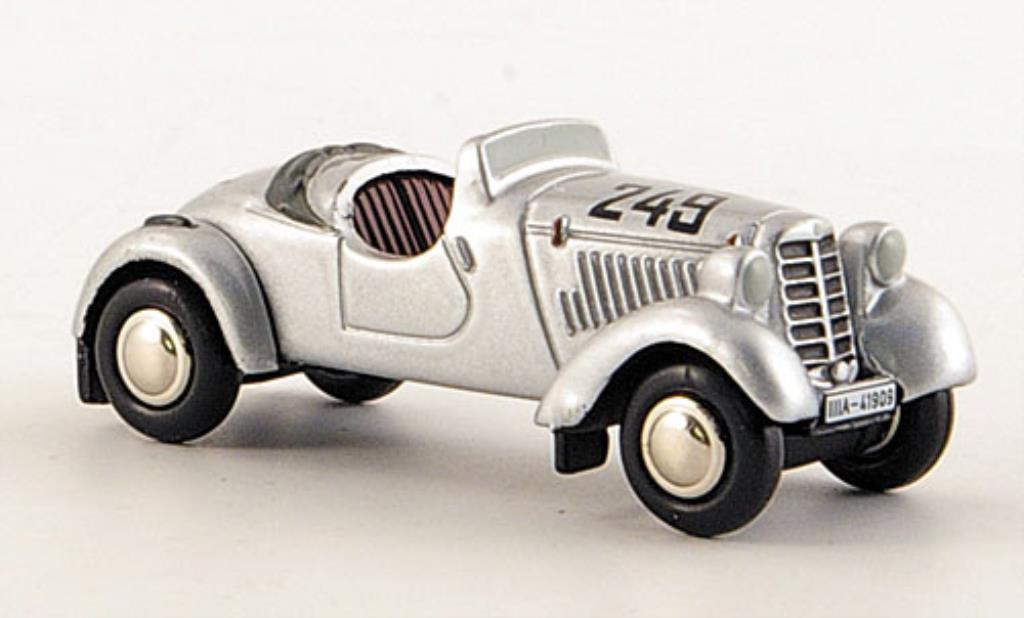Among the more creative prompts, if this car could transform into a futuristic vehicle, what new features might it gain? In an imaginative leap, this vintage race car would transform into a sleek, futuristic marvel. Its chassis would reconfigure into a smooth, chrome exoskeleton interlaced with neon blue highlights that pulse with energy. The wheels would retract for anti-gravity propulsion, allowing it to glide effortlessly above the ground. Equipped with an AI co-pilot system, it would navigate through both terrestrial roads and skyways with ease. The cockpit would feature a heads-up display projecting intricate maps and real-time data. A fusion reactor under the hood would provide near-unlimited power, and shape-shifting capabilities would allow the car to adapt to any environment — from submarine depths to Martian terrains. The car would retain its classic racing spirit, but with an unparalleled edge in this brave new world. 